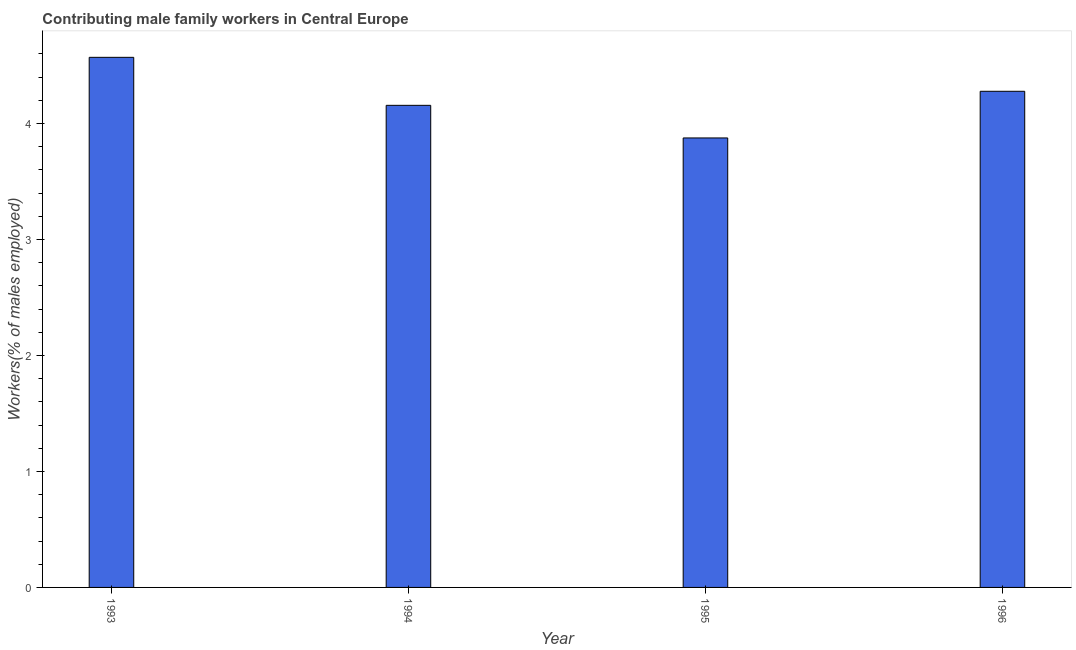Does the graph contain any zero values?
Your answer should be very brief. No. Does the graph contain grids?
Keep it short and to the point. No. What is the title of the graph?
Offer a terse response. Contributing male family workers in Central Europe. What is the label or title of the Y-axis?
Your answer should be compact. Workers(% of males employed). What is the contributing male family workers in 1996?
Make the answer very short. 4.28. Across all years, what is the maximum contributing male family workers?
Offer a terse response. 4.57. Across all years, what is the minimum contributing male family workers?
Your response must be concise. 3.87. In which year was the contributing male family workers minimum?
Give a very brief answer. 1995. What is the sum of the contributing male family workers?
Keep it short and to the point. 16.88. What is the difference between the contributing male family workers in 1994 and 1996?
Your answer should be compact. -0.12. What is the average contributing male family workers per year?
Your answer should be very brief. 4.22. What is the median contributing male family workers?
Provide a short and direct response. 4.22. In how many years, is the contributing male family workers greater than 0.4 %?
Ensure brevity in your answer.  4. What is the ratio of the contributing male family workers in 1995 to that in 1996?
Your answer should be very brief. 0.91. Is the contributing male family workers in 1993 less than that in 1994?
Provide a short and direct response. No. What is the difference between the highest and the second highest contributing male family workers?
Give a very brief answer. 0.29. What is the difference between the highest and the lowest contributing male family workers?
Ensure brevity in your answer.  0.69. In how many years, is the contributing male family workers greater than the average contributing male family workers taken over all years?
Give a very brief answer. 2. Are all the bars in the graph horizontal?
Keep it short and to the point. No. How many years are there in the graph?
Offer a terse response. 4. Are the values on the major ticks of Y-axis written in scientific E-notation?
Ensure brevity in your answer.  No. What is the Workers(% of males employed) of 1993?
Give a very brief answer. 4.57. What is the Workers(% of males employed) of 1994?
Ensure brevity in your answer.  4.16. What is the Workers(% of males employed) of 1995?
Offer a very short reply. 3.87. What is the Workers(% of males employed) of 1996?
Make the answer very short. 4.28. What is the difference between the Workers(% of males employed) in 1993 and 1994?
Make the answer very short. 0.41. What is the difference between the Workers(% of males employed) in 1993 and 1995?
Offer a terse response. 0.69. What is the difference between the Workers(% of males employed) in 1993 and 1996?
Make the answer very short. 0.29. What is the difference between the Workers(% of males employed) in 1994 and 1995?
Provide a succinct answer. 0.28. What is the difference between the Workers(% of males employed) in 1994 and 1996?
Give a very brief answer. -0.12. What is the difference between the Workers(% of males employed) in 1995 and 1996?
Make the answer very short. -0.4. What is the ratio of the Workers(% of males employed) in 1993 to that in 1995?
Provide a short and direct response. 1.18. What is the ratio of the Workers(% of males employed) in 1993 to that in 1996?
Your answer should be very brief. 1.07. What is the ratio of the Workers(% of males employed) in 1994 to that in 1995?
Provide a succinct answer. 1.07. What is the ratio of the Workers(% of males employed) in 1995 to that in 1996?
Offer a terse response. 0.91. 